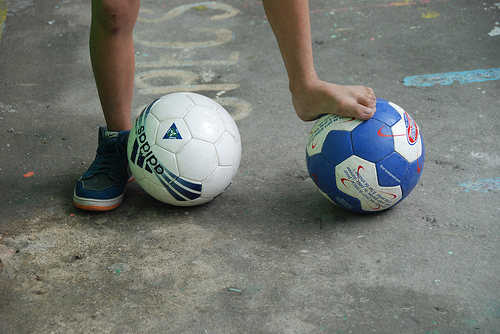<image>
Can you confirm if the shoe is to the right of the ball? Yes. From this viewpoint, the shoe is positioned to the right side relative to the ball. Is the soccer ball next to the person? Yes. The soccer ball is positioned adjacent to the person, located nearby in the same general area. 